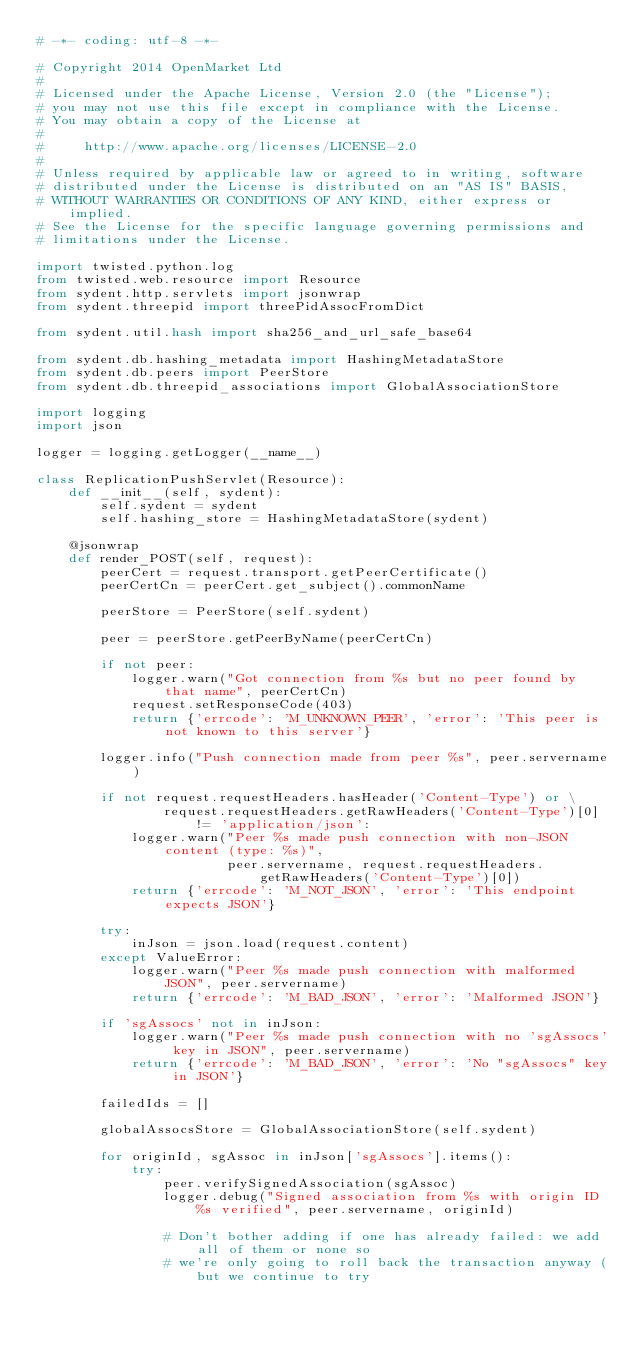<code> <loc_0><loc_0><loc_500><loc_500><_Python_># -*- coding: utf-8 -*-

# Copyright 2014 OpenMarket Ltd
#
# Licensed under the Apache License, Version 2.0 (the "License");
# you may not use this file except in compliance with the License.
# You may obtain a copy of the License at
#
#     http://www.apache.org/licenses/LICENSE-2.0
#
# Unless required by applicable law or agreed to in writing, software
# distributed under the License is distributed on an "AS IS" BASIS,
# WITHOUT WARRANTIES OR CONDITIONS OF ANY KIND, either express or implied.
# See the License for the specific language governing permissions and
# limitations under the License.

import twisted.python.log
from twisted.web.resource import Resource
from sydent.http.servlets import jsonwrap
from sydent.threepid import threePidAssocFromDict

from sydent.util.hash import sha256_and_url_safe_base64

from sydent.db.hashing_metadata import HashingMetadataStore
from sydent.db.peers import PeerStore
from sydent.db.threepid_associations import GlobalAssociationStore

import logging
import json

logger = logging.getLogger(__name__)

class ReplicationPushServlet(Resource):
    def __init__(self, sydent):
        self.sydent = sydent
        self.hashing_store = HashingMetadataStore(sydent)

    @jsonwrap
    def render_POST(self, request):
        peerCert = request.transport.getPeerCertificate()
        peerCertCn = peerCert.get_subject().commonName

        peerStore = PeerStore(self.sydent)

        peer = peerStore.getPeerByName(peerCertCn)

        if not peer:
            logger.warn("Got connection from %s but no peer found by that name", peerCertCn)
            request.setResponseCode(403)
            return {'errcode': 'M_UNKNOWN_PEER', 'error': 'This peer is not known to this server'}

        logger.info("Push connection made from peer %s", peer.servername)

        if not request.requestHeaders.hasHeader('Content-Type') or \
                request.requestHeaders.getRawHeaders('Content-Type')[0] != 'application/json':
            logger.warn("Peer %s made push connection with non-JSON content (type: %s)",
                        peer.servername, request.requestHeaders.getRawHeaders('Content-Type')[0])
            return {'errcode': 'M_NOT_JSON', 'error': 'This endpoint expects JSON'}

        try:
            inJson = json.load(request.content)
        except ValueError:
            logger.warn("Peer %s made push connection with malformed JSON", peer.servername)
            return {'errcode': 'M_BAD_JSON', 'error': 'Malformed JSON'}

        if 'sgAssocs' not in inJson:
            logger.warn("Peer %s made push connection with no 'sgAssocs' key in JSON", peer.servername)
            return {'errcode': 'M_BAD_JSON', 'error': 'No "sgAssocs" key in JSON'}

        failedIds = []

        globalAssocsStore = GlobalAssociationStore(self.sydent)

        for originId, sgAssoc in inJson['sgAssocs'].items():
            try:
                peer.verifySignedAssociation(sgAssoc)
                logger.debug("Signed association from %s with origin ID %s verified", peer.servername, originId)

                # Don't bother adding if one has already failed: we add all of them or none so
                # we're only going to roll back the transaction anyway (but we continue to try</code> 